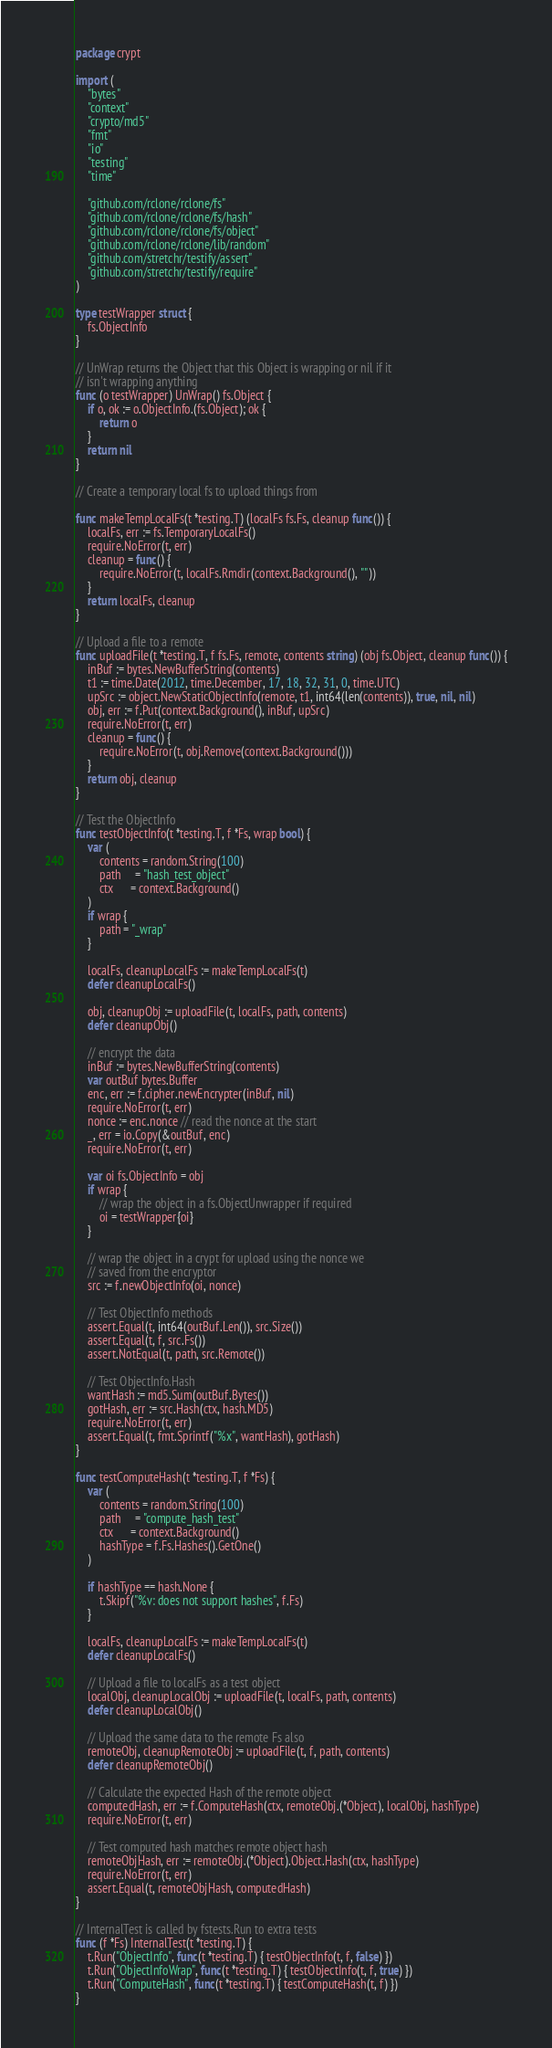<code> <loc_0><loc_0><loc_500><loc_500><_Go_>package crypt

import (
	"bytes"
	"context"
	"crypto/md5"
	"fmt"
	"io"
	"testing"
	"time"

	"github.com/rclone/rclone/fs"
	"github.com/rclone/rclone/fs/hash"
	"github.com/rclone/rclone/fs/object"
	"github.com/rclone/rclone/lib/random"
	"github.com/stretchr/testify/assert"
	"github.com/stretchr/testify/require"
)

type testWrapper struct {
	fs.ObjectInfo
}

// UnWrap returns the Object that this Object is wrapping or nil if it
// isn't wrapping anything
func (o testWrapper) UnWrap() fs.Object {
	if o, ok := o.ObjectInfo.(fs.Object); ok {
		return o
	}
	return nil
}

// Create a temporary local fs to upload things from

func makeTempLocalFs(t *testing.T) (localFs fs.Fs, cleanup func()) {
	localFs, err := fs.TemporaryLocalFs()
	require.NoError(t, err)
	cleanup = func() {
		require.NoError(t, localFs.Rmdir(context.Background(), ""))
	}
	return localFs, cleanup
}

// Upload a file to a remote
func uploadFile(t *testing.T, f fs.Fs, remote, contents string) (obj fs.Object, cleanup func()) {
	inBuf := bytes.NewBufferString(contents)
	t1 := time.Date(2012, time.December, 17, 18, 32, 31, 0, time.UTC)
	upSrc := object.NewStaticObjectInfo(remote, t1, int64(len(contents)), true, nil, nil)
	obj, err := f.Put(context.Background(), inBuf, upSrc)
	require.NoError(t, err)
	cleanup = func() {
		require.NoError(t, obj.Remove(context.Background()))
	}
	return obj, cleanup
}

// Test the ObjectInfo
func testObjectInfo(t *testing.T, f *Fs, wrap bool) {
	var (
		contents = random.String(100)
		path     = "hash_test_object"
		ctx      = context.Background()
	)
	if wrap {
		path = "_wrap"
	}

	localFs, cleanupLocalFs := makeTempLocalFs(t)
	defer cleanupLocalFs()

	obj, cleanupObj := uploadFile(t, localFs, path, contents)
	defer cleanupObj()

	// encrypt the data
	inBuf := bytes.NewBufferString(contents)
	var outBuf bytes.Buffer
	enc, err := f.cipher.newEncrypter(inBuf, nil)
	require.NoError(t, err)
	nonce := enc.nonce // read the nonce at the start
	_, err = io.Copy(&outBuf, enc)
	require.NoError(t, err)

	var oi fs.ObjectInfo = obj
	if wrap {
		// wrap the object in a fs.ObjectUnwrapper if required
		oi = testWrapper{oi}
	}

	// wrap the object in a crypt for upload using the nonce we
	// saved from the encryptor
	src := f.newObjectInfo(oi, nonce)

	// Test ObjectInfo methods
	assert.Equal(t, int64(outBuf.Len()), src.Size())
	assert.Equal(t, f, src.Fs())
	assert.NotEqual(t, path, src.Remote())

	// Test ObjectInfo.Hash
	wantHash := md5.Sum(outBuf.Bytes())
	gotHash, err := src.Hash(ctx, hash.MD5)
	require.NoError(t, err)
	assert.Equal(t, fmt.Sprintf("%x", wantHash), gotHash)
}

func testComputeHash(t *testing.T, f *Fs) {
	var (
		contents = random.String(100)
		path     = "compute_hash_test"
		ctx      = context.Background()
		hashType = f.Fs.Hashes().GetOne()
	)

	if hashType == hash.None {
		t.Skipf("%v: does not support hashes", f.Fs)
	}

	localFs, cleanupLocalFs := makeTempLocalFs(t)
	defer cleanupLocalFs()

	// Upload a file to localFs as a test object
	localObj, cleanupLocalObj := uploadFile(t, localFs, path, contents)
	defer cleanupLocalObj()

	// Upload the same data to the remote Fs also
	remoteObj, cleanupRemoteObj := uploadFile(t, f, path, contents)
	defer cleanupRemoteObj()

	// Calculate the expected Hash of the remote object
	computedHash, err := f.ComputeHash(ctx, remoteObj.(*Object), localObj, hashType)
	require.NoError(t, err)

	// Test computed hash matches remote object hash
	remoteObjHash, err := remoteObj.(*Object).Object.Hash(ctx, hashType)
	require.NoError(t, err)
	assert.Equal(t, remoteObjHash, computedHash)
}

// InternalTest is called by fstests.Run to extra tests
func (f *Fs) InternalTest(t *testing.T) {
	t.Run("ObjectInfo", func(t *testing.T) { testObjectInfo(t, f, false) })
	t.Run("ObjectInfoWrap", func(t *testing.T) { testObjectInfo(t, f, true) })
	t.Run("ComputeHash", func(t *testing.T) { testComputeHash(t, f) })
}
</code> 